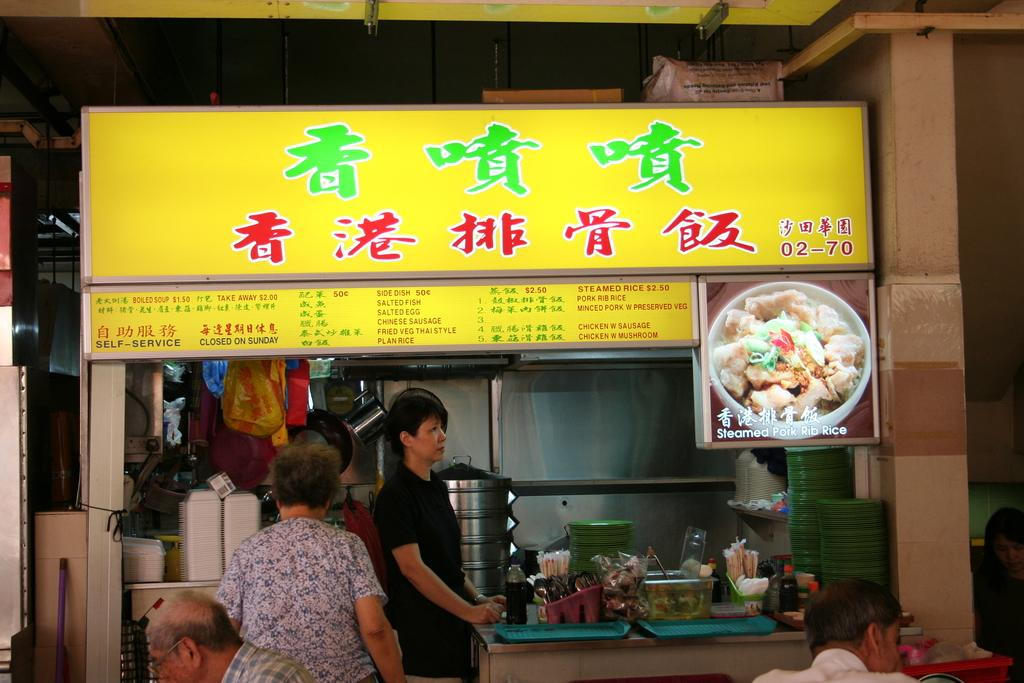How many people are in the image? There are four persons in the image. What is present in the image besides the people? There is a table in the image. What can be seen on the table? There are items on the table. What is visible in the background of the image? There is a shop in the background of the image. How is the ice distributed among the four persons in the image? There is no ice mentioned or visible in the image. Are the four persons sleeping in the image? There is no indication that the four persons are sleeping in the image; they are standing or sitting. 